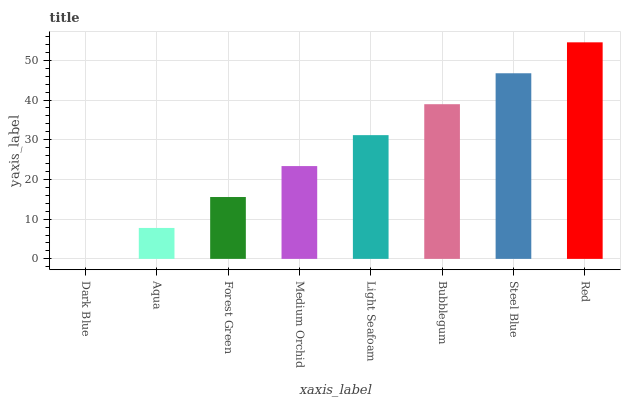Is Dark Blue the minimum?
Answer yes or no. Yes. Is Red the maximum?
Answer yes or no. Yes. Is Aqua the minimum?
Answer yes or no. No. Is Aqua the maximum?
Answer yes or no. No. Is Aqua greater than Dark Blue?
Answer yes or no. Yes. Is Dark Blue less than Aqua?
Answer yes or no. Yes. Is Dark Blue greater than Aqua?
Answer yes or no. No. Is Aqua less than Dark Blue?
Answer yes or no. No. Is Light Seafoam the high median?
Answer yes or no. Yes. Is Medium Orchid the low median?
Answer yes or no. Yes. Is Forest Green the high median?
Answer yes or no. No. Is Light Seafoam the low median?
Answer yes or no. No. 